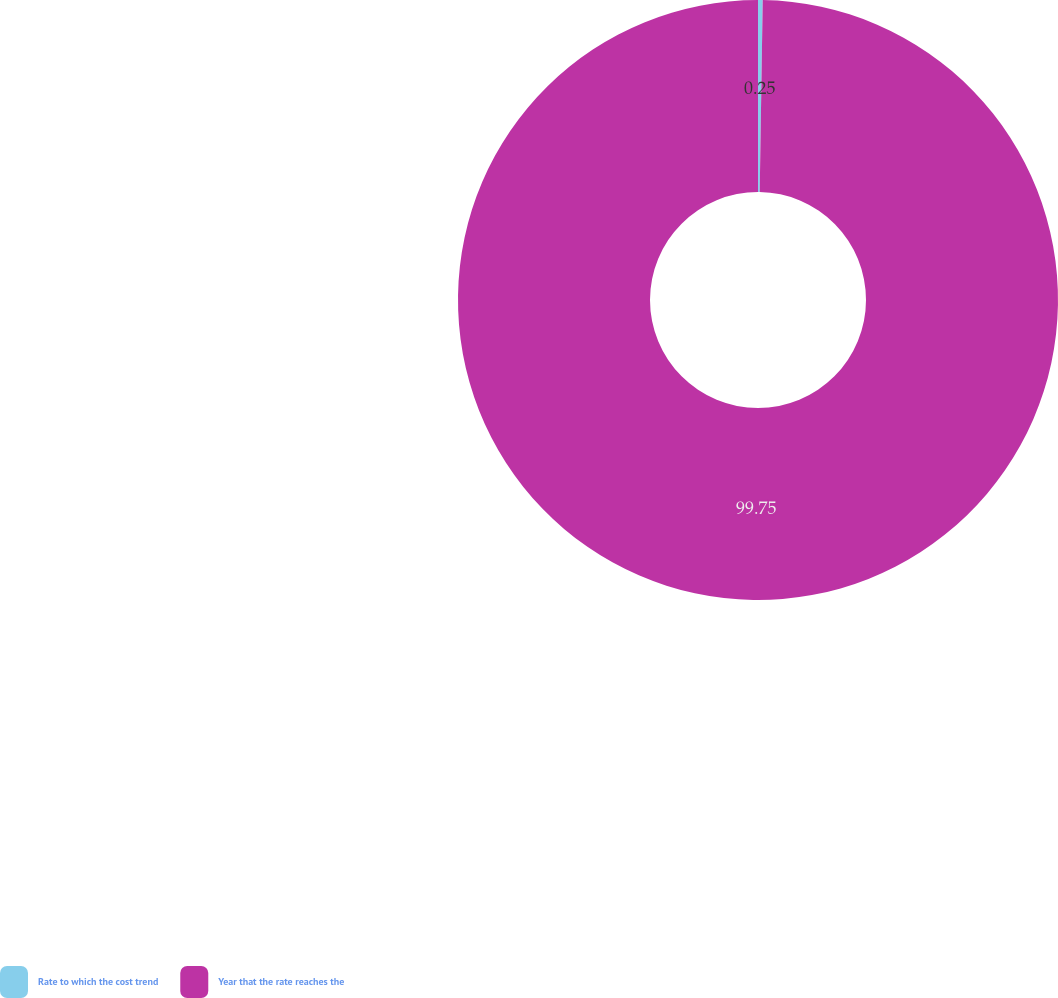<chart> <loc_0><loc_0><loc_500><loc_500><pie_chart><fcel>Rate to which the cost trend<fcel>Year that the rate reaches the<nl><fcel>0.25%<fcel>99.75%<nl></chart> 